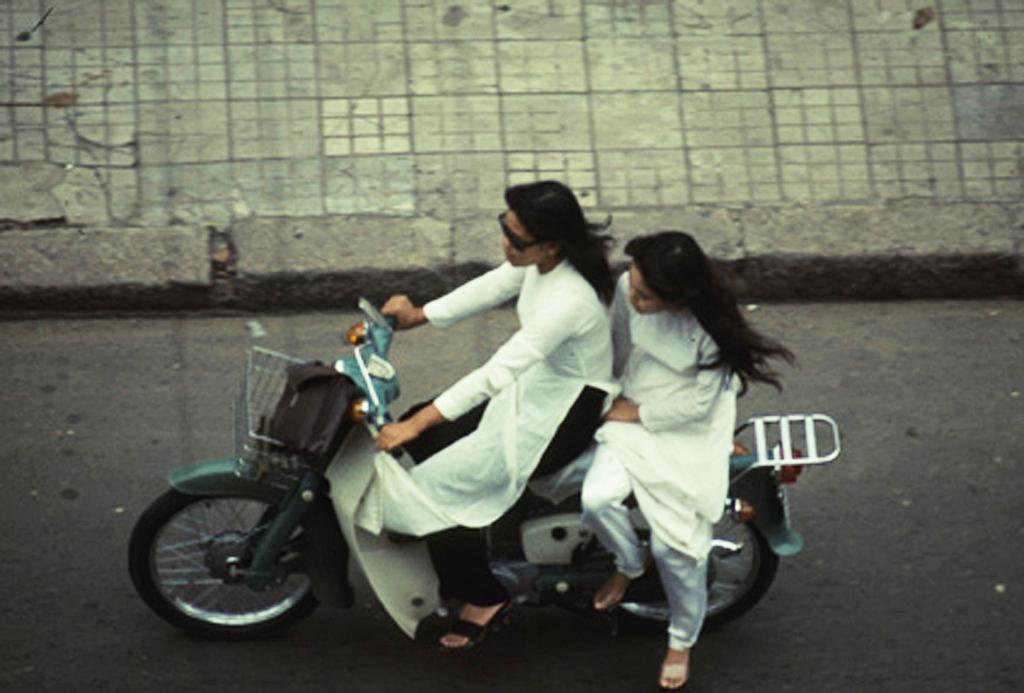How many people are in the image? There are two women in the image. What are the women doing in the image? The women are riding a bike. Where is the bike located in the image? The bike is on the road. What can be seen at the top of the image? There is a footpath visible at the top of the image. What route are the women's moms taking to meet them in the image? There is no mention of the women's moms or any route in the image. 